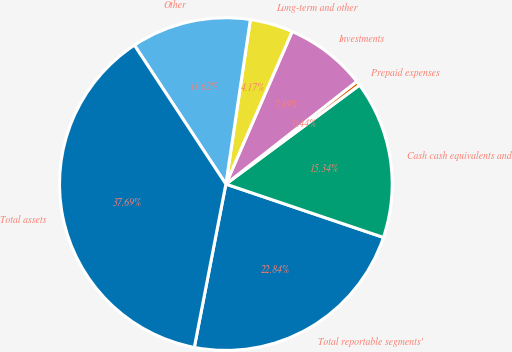Convert chart to OTSL. <chart><loc_0><loc_0><loc_500><loc_500><pie_chart><fcel>Total reportable segments'<fcel>Cash cash equivalents and<fcel>Prepaid expenses<fcel>Investments<fcel>Long-term and other<fcel>Other<fcel>Total assets<nl><fcel>22.84%<fcel>15.34%<fcel>0.44%<fcel>7.89%<fcel>4.17%<fcel>11.62%<fcel>37.69%<nl></chart> 